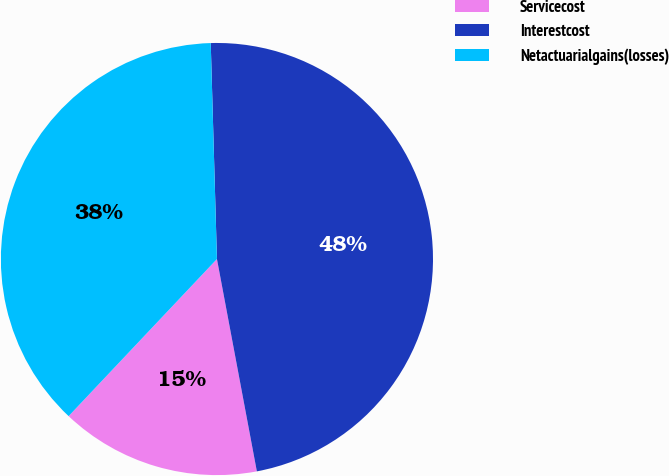<chart> <loc_0><loc_0><loc_500><loc_500><pie_chart><fcel>Servicecost<fcel>Interestcost<fcel>Netactuarialgains(losses)<nl><fcel>15.0%<fcel>47.5%<fcel>37.5%<nl></chart> 